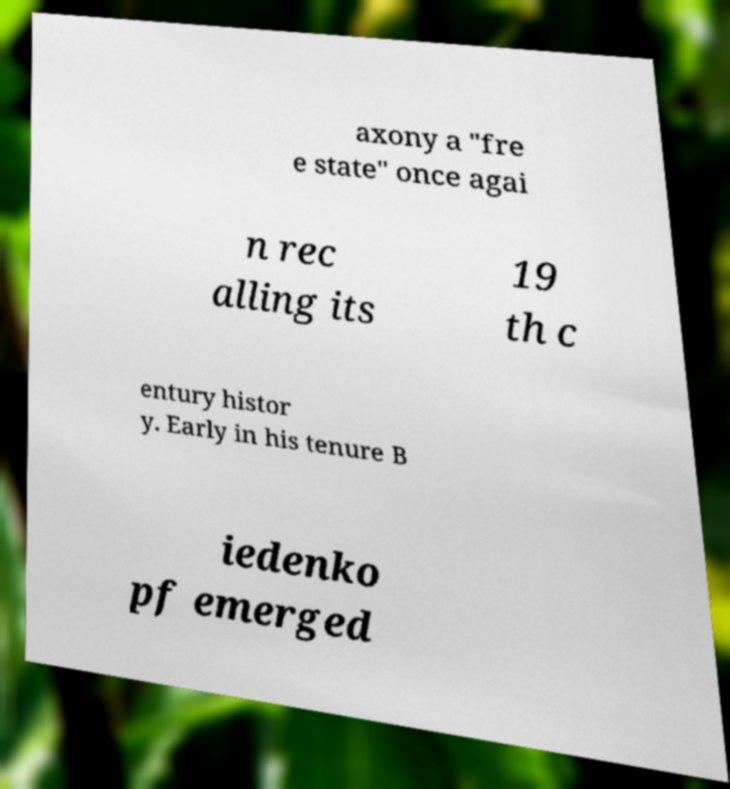Could you extract and type out the text from this image? axony a "fre e state" once agai n rec alling its 19 th c entury histor y. Early in his tenure B iedenko pf emerged 